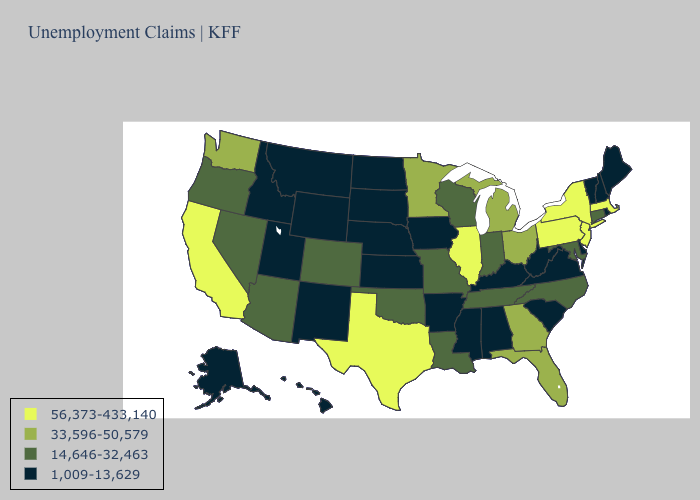What is the value of Arkansas?
Quick response, please. 1,009-13,629. Does Iowa have the lowest value in the USA?
Answer briefly. Yes. Does Vermont have the lowest value in the Northeast?
Be succinct. Yes. Which states have the lowest value in the USA?
Short answer required. Alabama, Alaska, Arkansas, Delaware, Hawaii, Idaho, Iowa, Kansas, Kentucky, Maine, Mississippi, Montana, Nebraska, New Hampshire, New Mexico, North Dakota, Rhode Island, South Carolina, South Dakota, Utah, Vermont, Virginia, West Virginia, Wyoming. Name the states that have a value in the range 56,373-433,140?
Keep it brief. California, Illinois, Massachusetts, New Jersey, New York, Pennsylvania, Texas. What is the value of Oregon?
Be succinct. 14,646-32,463. Does Alabama have the lowest value in the South?
Be succinct. Yes. What is the value of Kentucky?
Be succinct. 1,009-13,629. What is the value of Illinois?
Answer briefly. 56,373-433,140. What is the lowest value in states that border Maine?
Be succinct. 1,009-13,629. Among the states that border Maryland , does Pennsylvania have the lowest value?
Be succinct. No. What is the lowest value in states that border New York?
Short answer required. 1,009-13,629. Does the first symbol in the legend represent the smallest category?
Short answer required. No. Which states have the lowest value in the MidWest?
Be succinct. Iowa, Kansas, Nebraska, North Dakota, South Dakota. Which states have the highest value in the USA?
Write a very short answer. California, Illinois, Massachusetts, New Jersey, New York, Pennsylvania, Texas. 